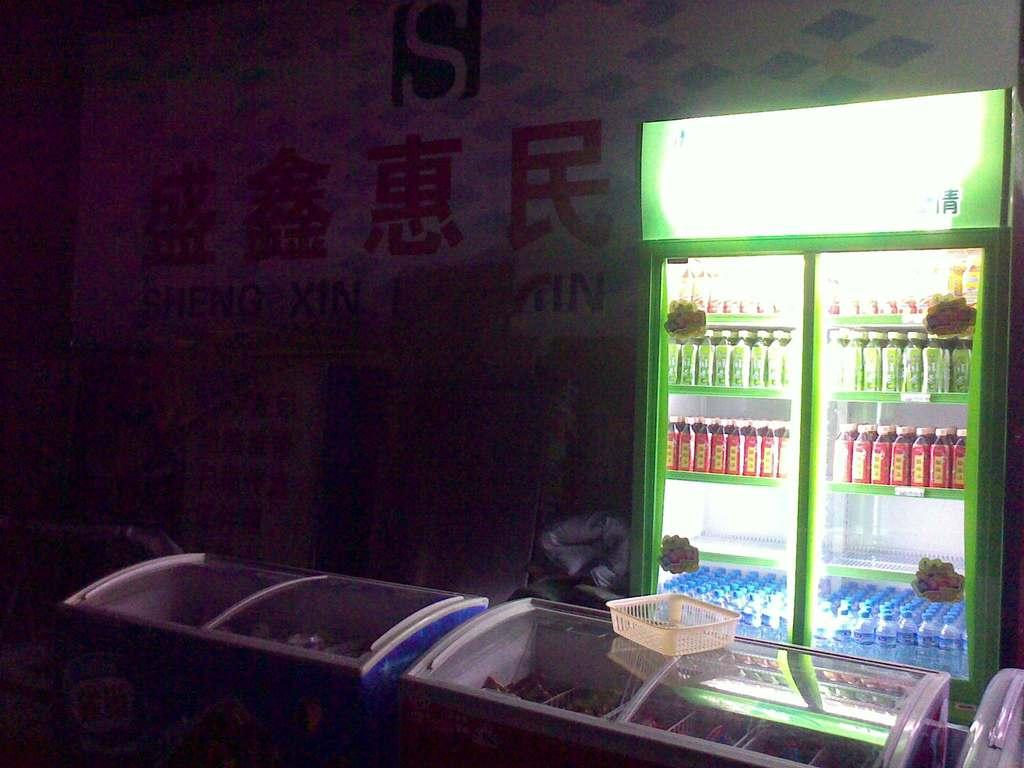Provide a one-sentence caption for the provided image. a display of brightly colored bottles in a dark chinese shop with a sign that has the letters "IN" on it. 